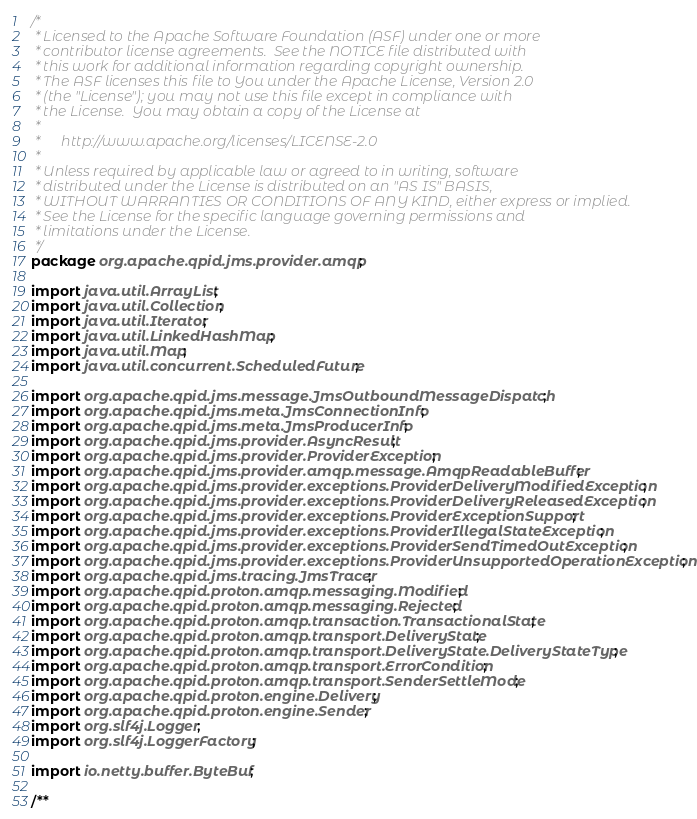<code> <loc_0><loc_0><loc_500><loc_500><_Java_>/*
 * Licensed to the Apache Software Foundation (ASF) under one or more
 * contributor license agreements.  See the NOTICE file distributed with
 * this work for additional information regarding copyright ownership.
 * The ASF licenses this file to You under the Apache License, Version 2.0
 * (the "License"); you may not use this file except in compliance with
 * the License.  You may obtain a copy of the License at
 *
 *      http://www.apache.org/licenses/LICENSE-2.0
 *
 * Unless required by applicable law or agreed to in writing, software
 * distributed under the License is distributed on an "AS IS" BASIS,
 * WITHOUT WARRANTIES OR CONDITIONS OF ANY KIND, either express or implied.
 * See the License for the specific language governing permissions and
 * limitations under the License.
 */
package org.apache.qpid.jms.provider.amqp;

import java.util.ArrayList;
import java.util.Collection;
import java.util.Iterator;
import java.util.LinkedHashMap;
import java.util.Map;
import java.util.concurrent.ScheduledFuture;

import org.apache.qpid.jms.message.JmsOutboundMessageDispatch;
import org.apache.qpid.jms.meta.JmsConnectionInfo;
import org.apache.qpid.jms.meta.JmsProducerInfo;
import org.apache.qpid.jms.provider.AsyncResult;
import org.apache.qpid.jms.provider.ProviderException;
import org.apache.qpid.jms.provider.amqp.message.AmqpReadableBuffer;
import org.apache.qpid.jms.provider.exceptions.ProviderDeliveryModifiedException;
import org.apache.qpid.jms.provider.exceptions.ProviderDeliveryReleasedException;
import org.apache.qpid.jms.provider.exceptions.ProviderExceptionSupport;
import org.apache.qpid.jms.provider.exceptions.ProviderIllegalStateException;
import org.apache.qpid.jms.provider.exceptions.ProviderSendTimedOutException;
import org.apache.qpid.jms.provider.exceptions.ProviderUnsupportedOperationException;
import org.apache.qpid.jms.tracing.JmsTracer;
import org.apache.qpid.proton.amqp.messaging.Modified;
import org.apache.qpid.proton.amqp.messaging.Rejected;
import org.apache.qpid.proton.amqp.transaction.TransactionalState;
import org.apache.qpid.proton.amqp.transport.DeliveryState;
import org.apache.qpid.proton.amqp.transport.DeliveryState.DeliveryStateType;
import org.apache.qpid.proton.amqp.transport.ErrorCondition;
import org.apache.qpid.proton.amqp.transport.SenderSettleMode;
import org.apache.qpid.proton.engine.Delivery;
import org.apache.qpid.proton.engine.Sender;
import org.slf4j.Logger;
import org.slf4j.LoggerFactory;

import io.netty.buffer.ByteBuf;

/**</code> 